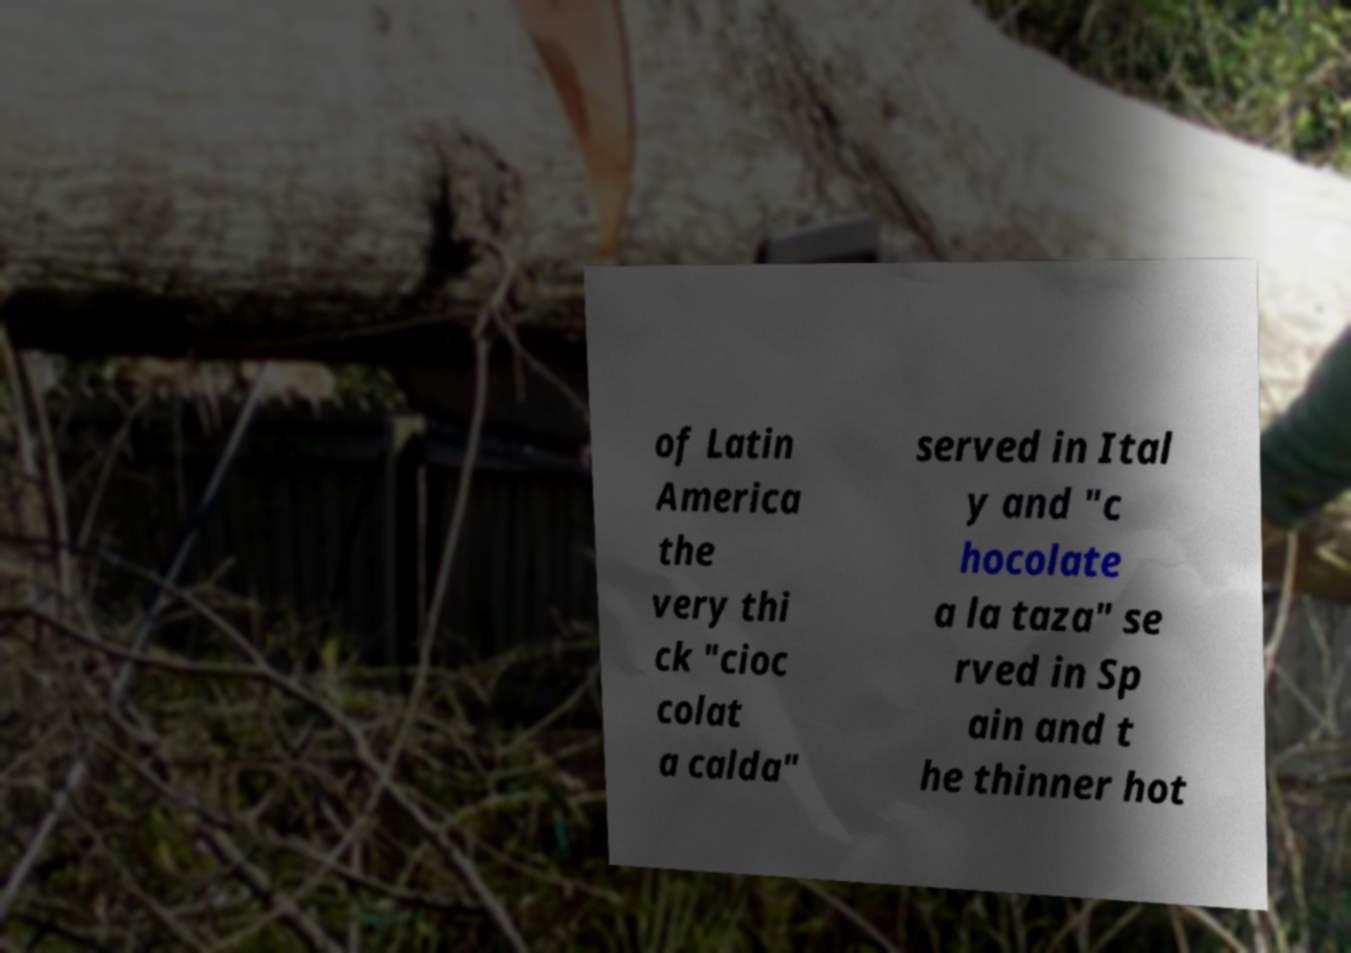Can you read and provide the text displayed in the image?This photo seems to have some interesting text. Can you extract and type it out for me? of Latin America the very thi ck "cioc colat a calda" served in Ital y and "c hocolate a la taza" se rved in Sp ain and t he thinner hot 